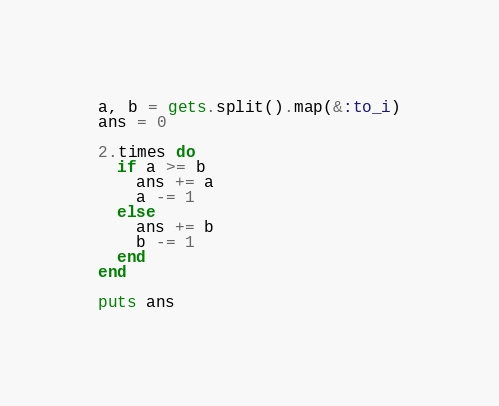Convert code to text. <code><loc_0><loc_0><loc_500><loc_500><_Ruby_>a, b = gets.split().map(&:to_i)
ans = 0

2.times do
  if a >= b
    ans += a
    a -= 1
  else
    ans += b
    b -= 1
  end
end

puts ans </code> 